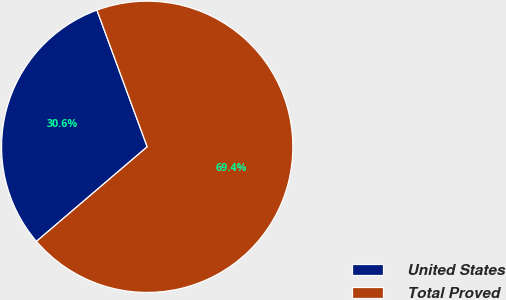<chart> <loc_0><loc_0><loc_500><loc_500><pie_chart><fcel>United States<fcel>Total Proved<nl><fcel>30.64%<fcel>69.36%<nl></chart> 